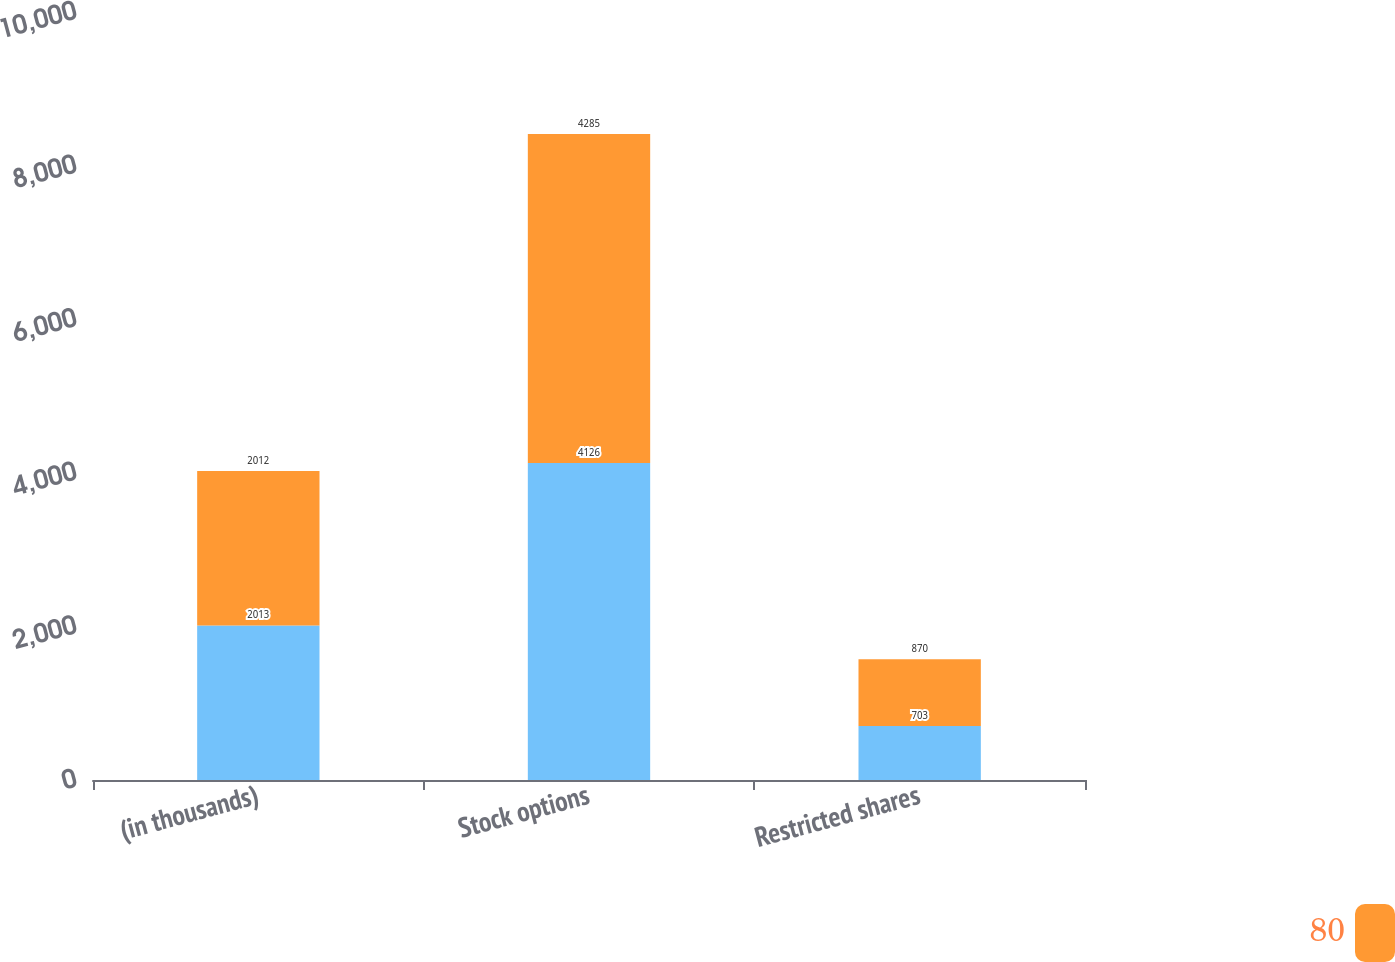<chart> <loc_0><loc_0><loc_500><loc_500><stacked_bar_chart><ecel><fcel>(in thousands)<fcel>Stock options<fcel>Restricted shares<nl><fcel>nan<fcel>2013<fcel>4126<fcel>703<nl><fcel>80<fcel>2012<fcel>4285<fcel>870<nl></chart> 